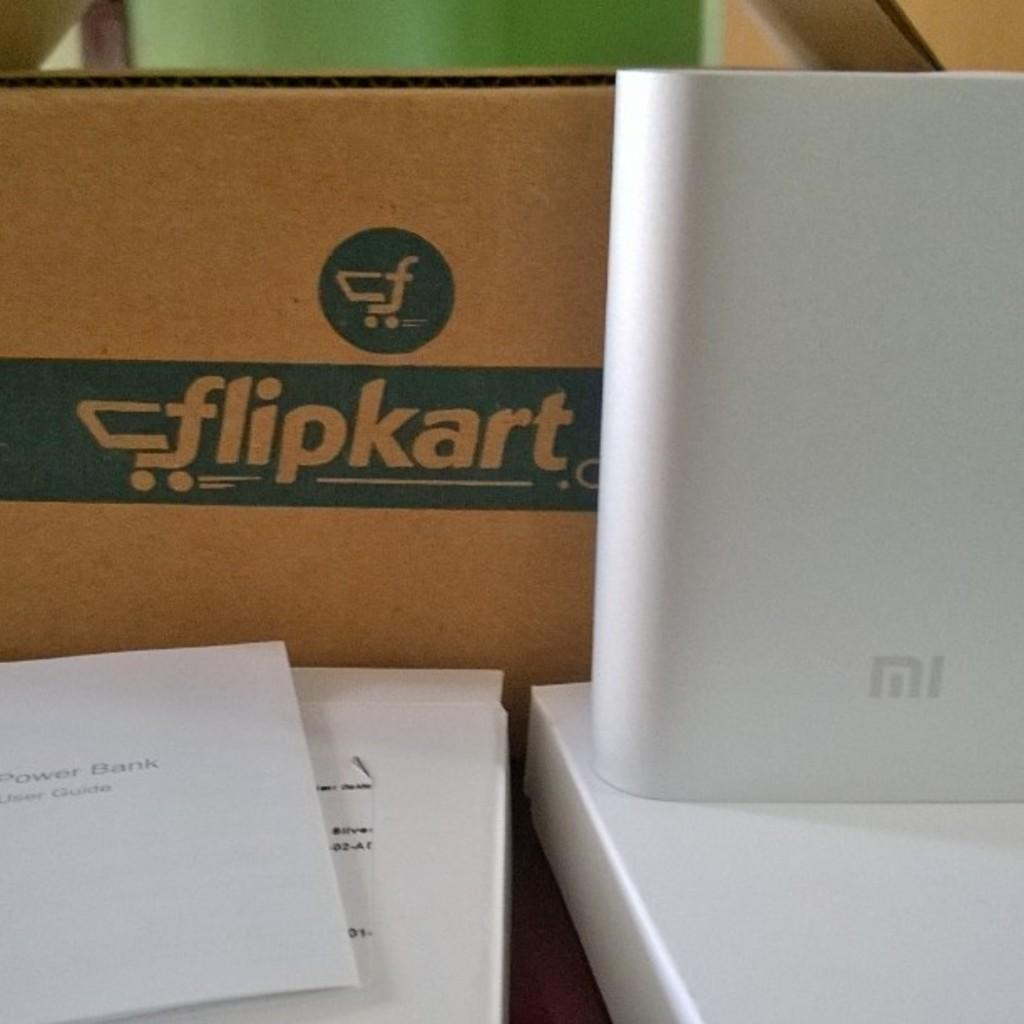Provide a one-sentence caption for the provided image. A box that says flipkart sits next to a white electronic device. 